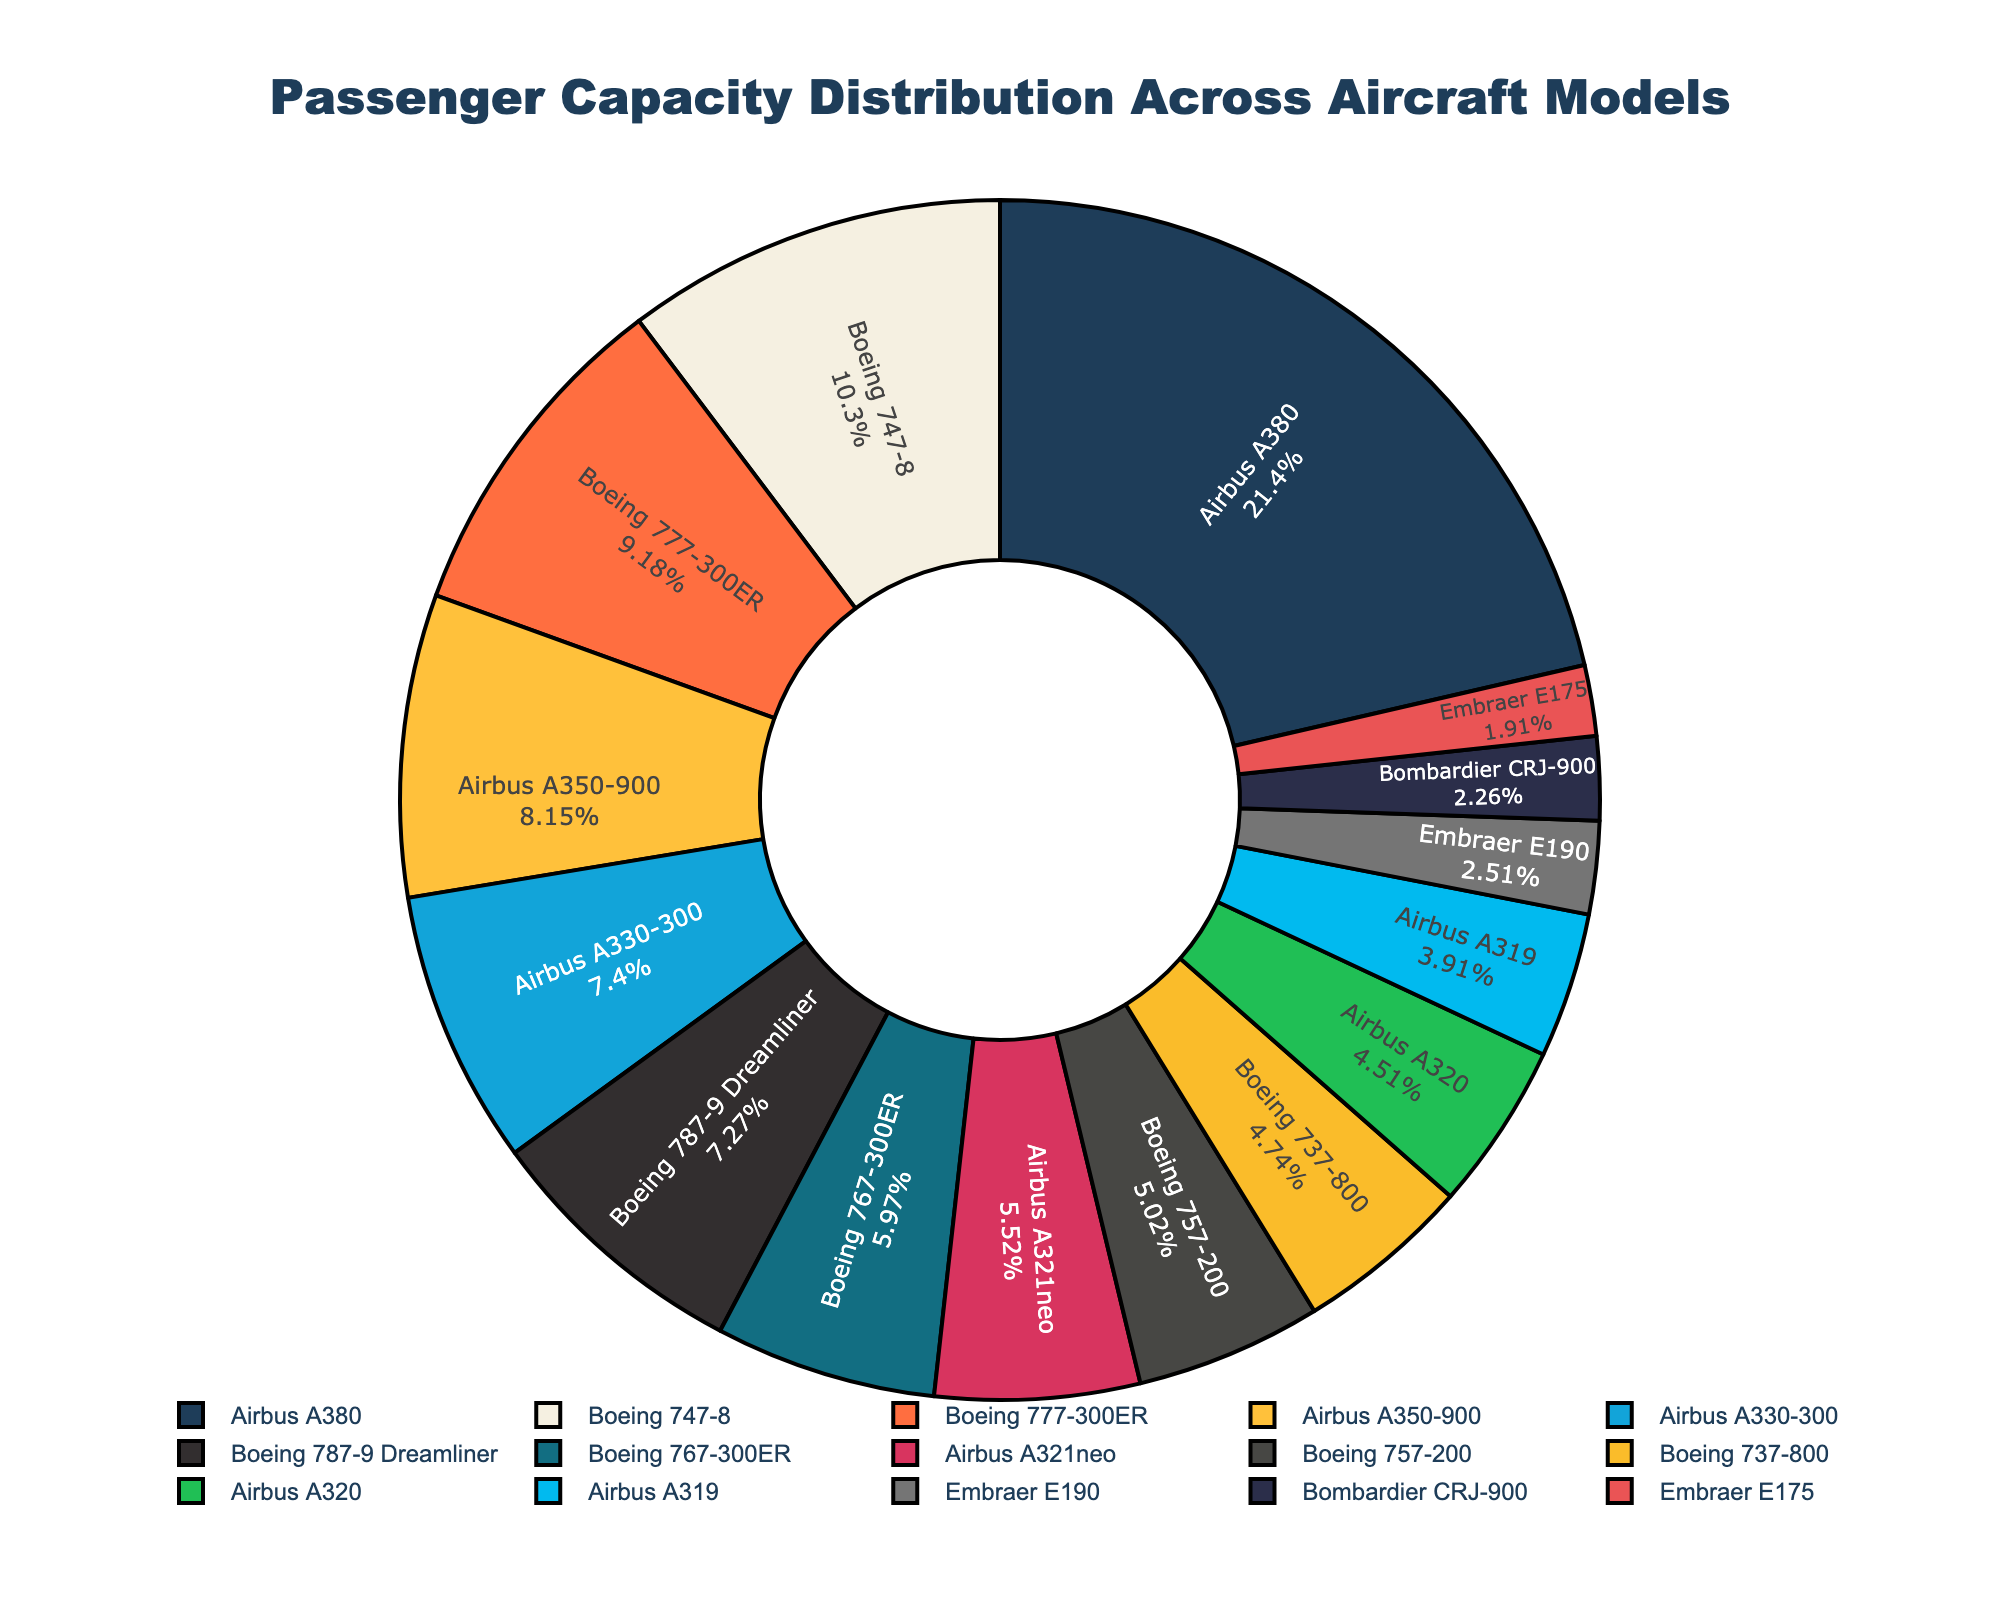What percent of the total passenger capacity is represented by the Airbus A380? Identify the Airbus A380 section in the pie chart. Its percentage value is directly shown inside this section.
Answer: 20% Which aircraft model has the highest passenger capacity? Look for the portion of the pie chart that is the largest. The largest portion belongs to the Airbus A380.
Answer: Airbus A380 How does the passenger capacity of the Boeing 747-8 compare to that of the Boeing 777-300ER? Look at the sizes of the sections for the Boeing 747-8 and the Boeing 777-300ER in the chart. The Boeing 747-8 has a larger section, indicating a higher passenger capacity.
Answer: Boeing 747-8 has a higher capacity What is the total passenger capacity for all Embraer models combined? Find the sections for Embraer E175 and Embraer E190. Sum their capacities: 76 (E175) + 100 (E190).
Answer: 176 What is the difference in passenger capacity between Airbus A350-900 and Boeing 787-9 Dreamliner? Find the capacities for both (325 for A350-900 and 290 for 787-9). Subtract the capacity of the Boeing 787-9 from that of the Airbus A350-900: 325 - 290.
Answer: 35 What is the average passenger capacity of all aircraft models shown in the chart? To find the average, first sum all the capacities: 189 + 180 + 290 + 295 + 76 + 366 + 220 + 90 + 410 + 325 + 238 + 156 + 100 + 200 + 853 = 3988. There are 15 models, so divide the sum by 15: 3988 / 15.
Answer: 265.87 Which aircraft model has the smallest section in the pie chart? Look for the smallest visual section in the chart. This section belongs to the Embraer E175.
Answer: Embraer E175 What is the combined passenger capacity of all Boeing models? Identify all Boeing models: 737-800 (189), 787-9 (290), 777-300ER (366), 747-8 (410), 767-300ER (238), and 757-200 (200). Sum their capacities: 189 + 290 + 366 + 410 + 238 + 200.
Answer: 1693 